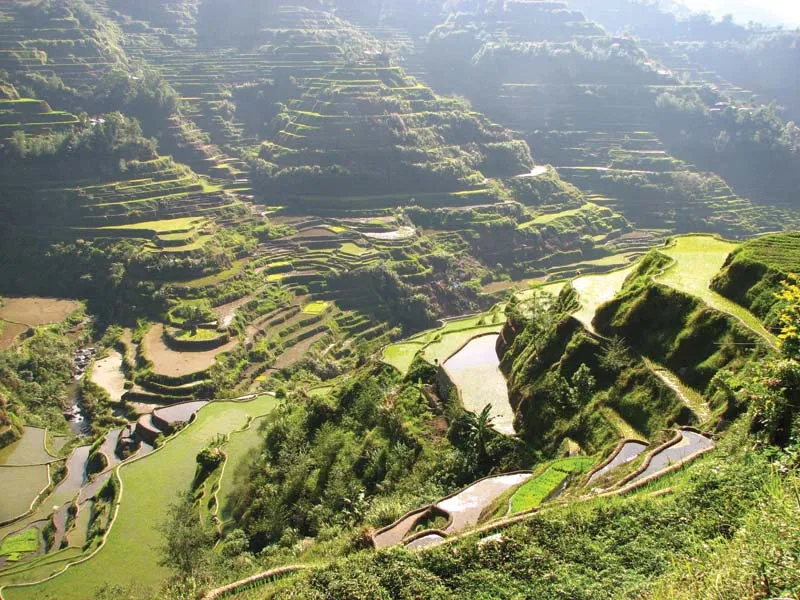Can you describe the historical significance of the terraces seen in this image? The Banaue Rice Terraces are a testament to ancient engineering and agricultural practices, dating back over 2,000 years. Built by the Ifugao people, these terraces reflect their sophisticated understanding of irrigation and soil management. They are considered a UNESCO World Heritage Site, symbolizing the cultural heritage and resilience of indigenous practices in the Philippines. The terraces not only represent sustainable agricultural techniques but also embody the deeply rooted connection between the Ifugao people and their environment, passed down through countless generations. How do these terraces impact the local economy today? Today, the Banaue Rice Terraces play a crucial role in the local economy through both agriculture and tourism. The terraces continue to be used for rice farming, a staple crop, supporting local livelihoods. Additionally, the terraces attract numerous tourists each year, drawn by their beauty and historical significance. This tourism influx provides income through guided tours, local handicrafts, and cultural performances, thereby diversifying the economic activities in the region and promoting sustainable development. 